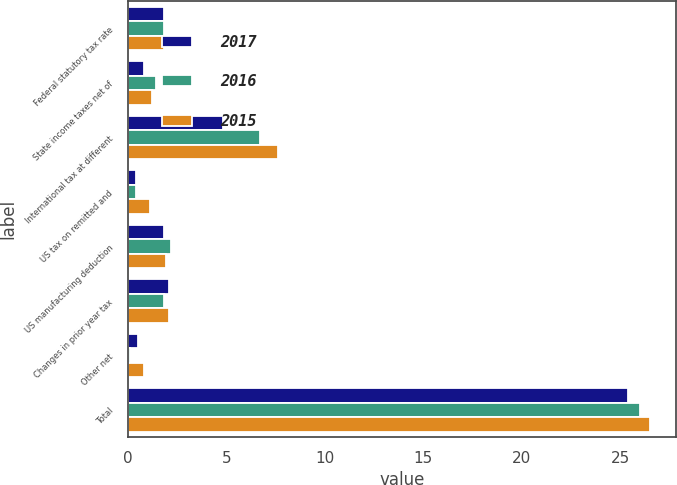Convert chart to OTSL. <chart><loc_0><loc_0><loc_500><loc_500><stacked_bar_chart><ecel><fcel>Federal statutory tax rate<fcel>State income taxes net of<fcel>International tax at different<fcel>US tax on remitted and<fcel>US manufacturing deduction<fcel>Changes in prior year tax<fcel>Other net<fcel>Total<nl><fcel>2017<fcel>1.8<fcel>0.8<fcel>4.8<fcel>0.4<fcel>1.8<fcel>2.1<fcel>0.5<fcel>25.4<nl><fcel>2016<fcel>1.8<fcel>1.4<fcel>6.7<fcel>0.4<fcel>2.2<fcel>1.8<fcel>0.1<fcel>26<nl><fcel>2015<fcel>1.8<fcel>1.2<fcel>7.6<fcel>1.1<fcel>1.9<fcel>2.1<fcel>0.8<fcel>26.5<nl></chart> 